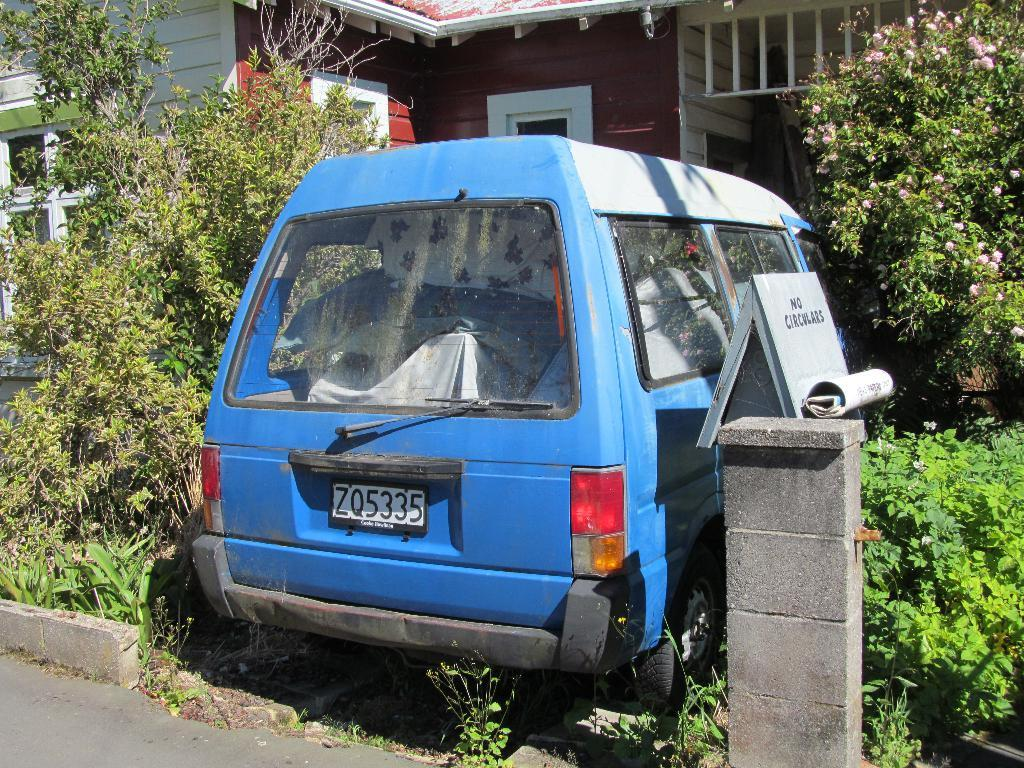<image>
Provide a brief description of the given image. A blue minivan parked in some greenery with a no circulars sign next  to it. 